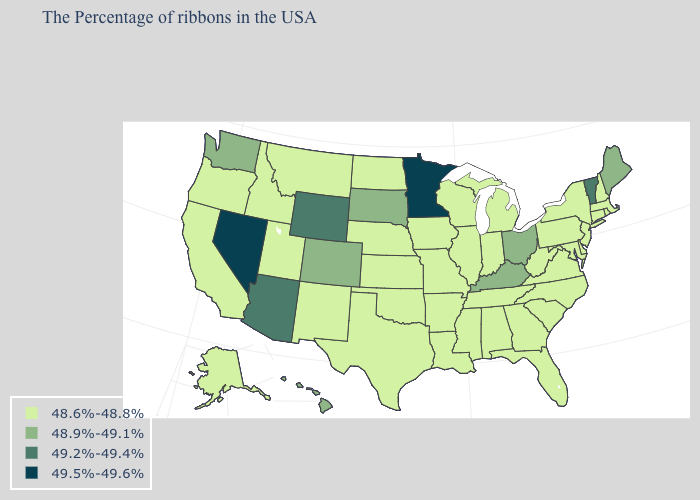Which states hav the highest value in the MidWest?
Be succinct. Minnesota. What is the value of Virginia?
Short answer required. 48.6%-48.8%. Which states have the highest value in the USA?
Quick response, please. Minnesota, Nevada. What is the value of North Dakota?
Be succinct. 48.6%-48.8%. How many symbols are there in the legend?
Answer briefly. 4. What is the value of Hawaii?
Give a very brief answer. 48.9%-49.1%. Does Kentucky have the highest value in the USA?
Short answer required. No. What is the value of Nevada?
Keep it brief. 49.5%-49.6%. Does Minnesota have a higher value than New York?
Write a very short answer. Yes. Name the states that have a value in the range 48.9%-49.1%?
Be succinct. Maine, Ohio, Kentucky, South Dakota, Colorado, Washington, Hawaii. What is the highest value in the USA?
Give a very brief answer. 49.5%-49.6%. Name the states that have a value in the range 49.5%-49.6%?
Give a very brief answer. Minnesota, Nevada. Name the states that have a value in the range 48.6%-48.8%?
Give a very brief answer. Massachusetts, Rhode Island, New Hampshire, Connecticut, New York, New Jersey, Delaware, Maryland, Pennsylvania, Virginia, North Carolina, South Carolina, West Virginia, Florida, Georgia, Michigan, Indiana, Alabama, Tennessee, Wisconsin, Illinois, Mississippi, Louisiana, Missouri, Arkansas, Iowa, Kansas, Nebraska, Oklahoma, Texas, North Dakota, New Mexico, Utah, Montana, Idaho, California, Oregon, Alaska. What is the value of South Dakota?
Quick response, please. 48.9%-49.1%. 